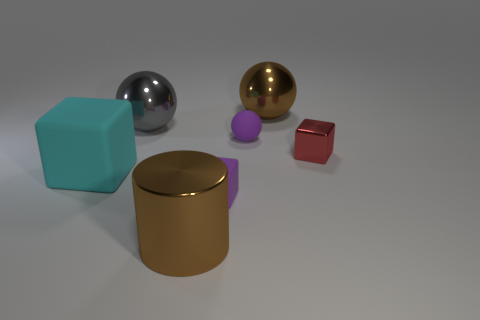What number of things are the same size as the cyan cube?
Provide a succinct answer. 3. How many things are either brown spheres or metallic balls that are to the left of the cylinder?
Ensure brevity in your answer.  2. There is a tiny red metallic thing; what shape is it?
Provide a short and direct response. Cube. Is the color of the tiny matte sphere the same as the big rubber thing?
Your answer should be very brief. No. There is another block that is the same size as the red block; what is its color?
Provide a succinct answer. Purple. How many cyan things are metal blocks or matte blocks?
Provide a succinct answer. 1. Is the number of big brown balls greater than the number of shiny objects?
Ensure brevity in your answer.  No. Is the size of the brown object in front of the small purple ball the same as the sphere left of the big brown shiny cylinder?
Offer a terse response. Yes. The tiny block on the right side of the purple rubber ball that is on the right side of the small purple rubber object in front of the cyan thing is what color?
Make the answer very short. Red. Is there another large matte object that has the same shape as the cyan matte object?
Make the answer very short. No. 